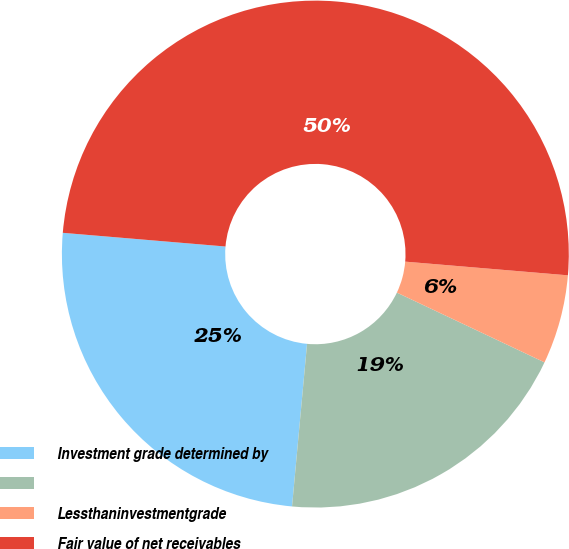<chart> <loc_0><loc_0><loc_500><loc_500><pie_chart><fcel>Investment grade determined by<fcel>Unnamed: 1<fcel>Lessthaninvestmentgrade<fcel>Fair value of net receivables<nl><fcel>24.87%<fcel>19.44%<fcel>5.69%<fcel>50.0%<nl></chart> 